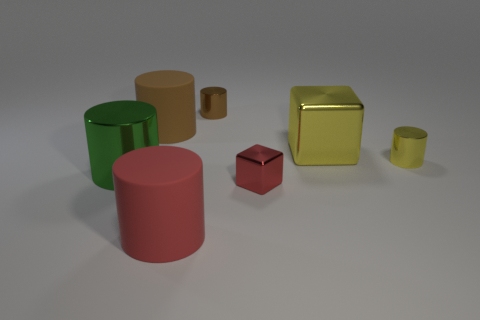Add 1 red rubber spheres. How many objects exist? 8 Subtract all cubes. How many objects are left? 5 Subtract 4 cylinders. How many cylinders are left? 1 Subtract all yellow blocks. Subtract all brown cylinders. How many blocks are left? 1 Subtract all yellow cubes. How many green cylinders are left? 1 Subtract all brown shiny cylinders. Subtract all big brown matte cylinders. How many objects are left? 5 Add 7 large red matte things. How many large red matte things are left? 8 Add 1 red rubber cylinders. How many red rubber cylinders exist? 2 Subtract all green cylinders. How many cylinders are left? 4 Subtract all large metallic cylinders. How many cylinders are left? 4 